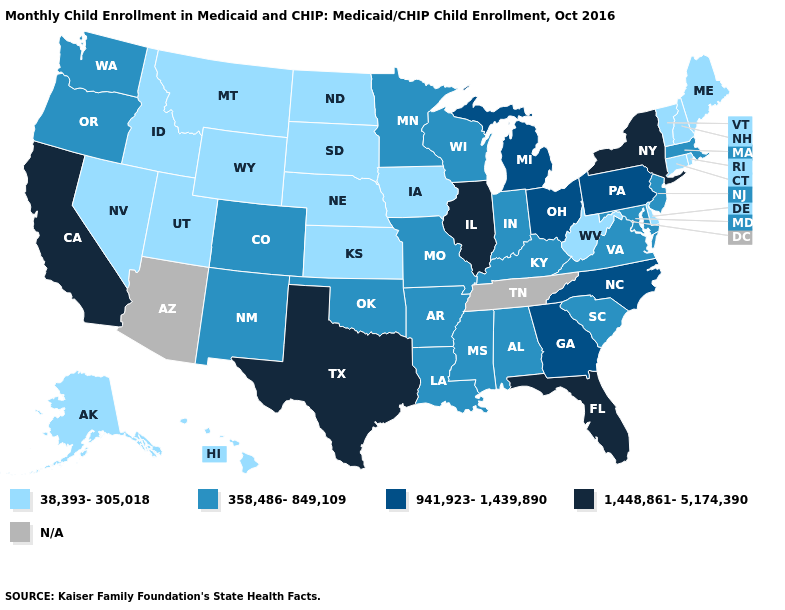How many symbols are there in the legend?
Keep it brief. 5. What is the lowest value in the MidWest?
Answer briefly. 38,393-305,018. What is the highest value in the USA?
Give a very brief answer. 1,448,861-5,174,390. Among the states that border Tennessee , does Missouri have the highest value?
Answer briefly. No. Name the states that have a value in the range 1,448,861-5,174,390?
Write a very short answer. California, Florida, Illinois, New York, Texas. Is the legend a continuous bar?
Concise answer only. No. Does Wyoming have the lowest value in the USA?
Answer briefly. Yes. What is the value of Wyoming?
Give a very brief answer. 38,393-305,018. Which states have the highest value in the USA?
Give a very brief answer. California, Florida, Illinois, New York, Texas. What is the highest value in the USA?
Give a very brief answer. 1,448,861-5,174,390. Name the states that have a value in the range 38,393-305,018?
Short answer required. Alaska, Connecticut, Delaware, Hawaii, Idaho, Iowa, Kansas, Maine, Montana, Nebraska, Nevada, New Hampshire, North Dakota, Rhode Island, South Dakota, Utah, Vermont, West Virginia, Wyoming. Does South Dakota have the highest value in the USA?
Keep it brief. No. Among the states that border Connecticut , does Rhode Island have the highest value?
Short answer required. No. 